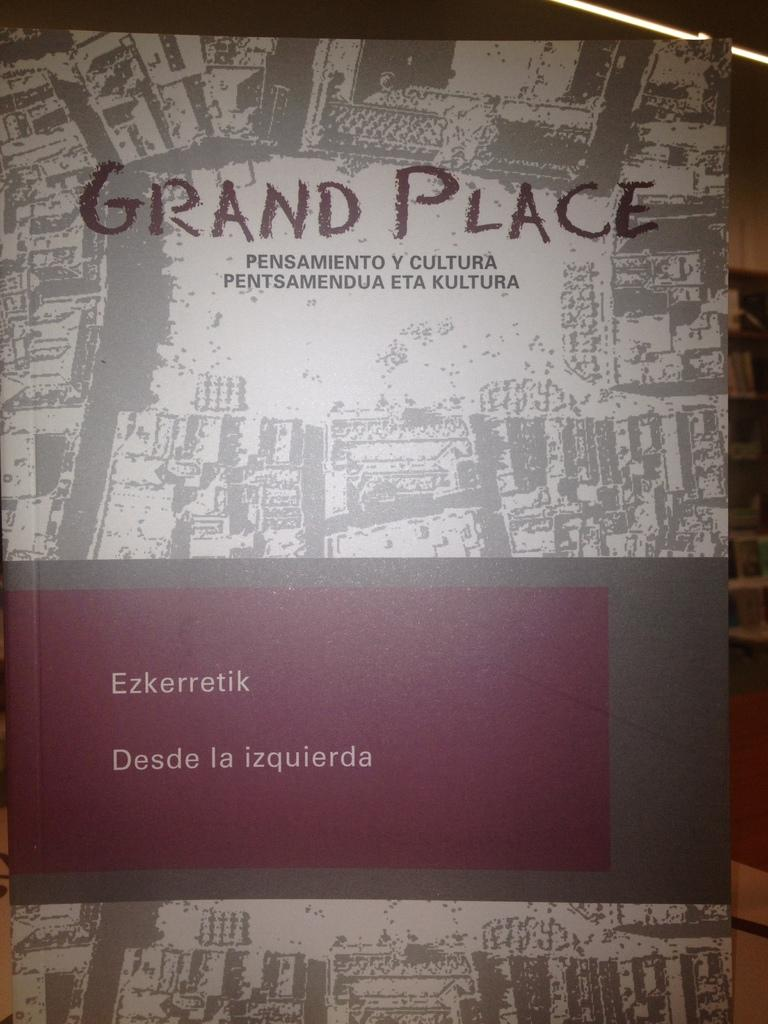What object is present in the image? There is a book in the image. What type of object is the book? The book is a physical object, typically made of paper and containing written or printed content. What might someone do with the book in the image? Someone might read the book, write in it, or use it as a reference or decoration. What type of neck accessory is visible in the image? There is no neck accessory present in the image; it only features a book. 